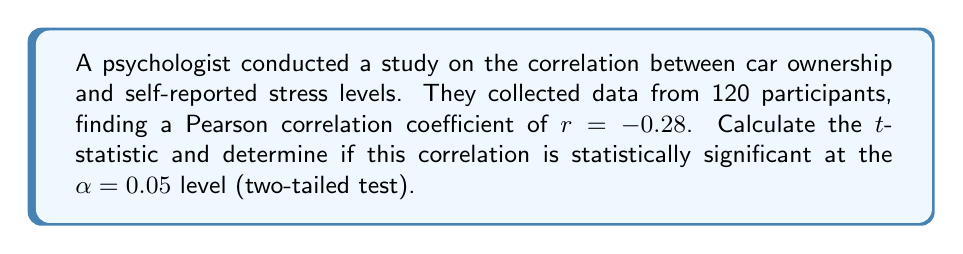Teach me how to tackle this problem. To determine the statistical significance of the correlation, we need to follow these steps:

1. Calculate the t-statistic using the formula:
   $$t = \frac{r\sqrt{n-2}}{\sqrt{1-r^2}}$$
   where r is the correlation coefficient and n is the sample size.

2. Determine the degrees of freedom (df):
   $$df = n - 2 = 120 - 2 = 118$$

3. Find the critical t-value for a two-tailed test at α = 0.05 with df = 118.

4. Compare the calculated t-statistic with the critical t-value.

Step 1: Calculate the t-statistic
$$t = \frac{-0.28\sqrt{120-2}}{\sqrt{1-(-0.28)^2}}$$
$$t = \frac{-0.28\sqrt{118}}{\sqrt{1-0.0784}}$$
$$t = \frac{-0.28 * 10.8628}{0.9619}$$
$$t = -3.1658$$

Step 2: Degrees of freedom (df) = 118 (already calculated)

Step 3: The critical t-value for a two-tailed test at α = 0.05 with df = 118 is approximately ±1.9803 (from t-distribution tables or statistical software).

Step 4: Compare the calculated t-statistic (-3.1658) with the critical t-value (±1.9803).

Since the absolute value of the calculated t-statistic (3.1658) is greater than the critical t-value (1.9803), we reject the null hypothesis.

Therefore, the correlation between car ownership and self-reported stress levels is statistically significant at the α = 0.05 level.
Answer: Statistically significant (t = -3.1658, p < 0.05) 